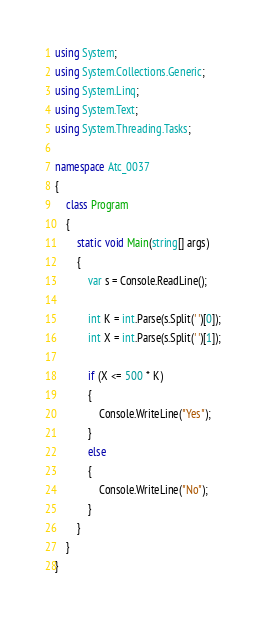Convert code to text. <code><loc_0><loc_0><loc_500><loc_500><_C#_>using System;
using System.Collections.Generic;
using System.Linq;
using System.Text;
using System.Threading.Tasks;

namespace Atc_0037
{
    class Program
    {
        static void Main(string[] args)
        {
            var s = Console.ReadLine();

            int K = int.Parse(s.Split(' ')[0]);
            int X = int.Parse(s.Split(' ')[1]);

            if (X <= 500 * K)
            {
                Console.WriteLine("Yes");
            }
            else
            {
                Console.WriteLine("No");
            }
        }
    }
}
</code> 